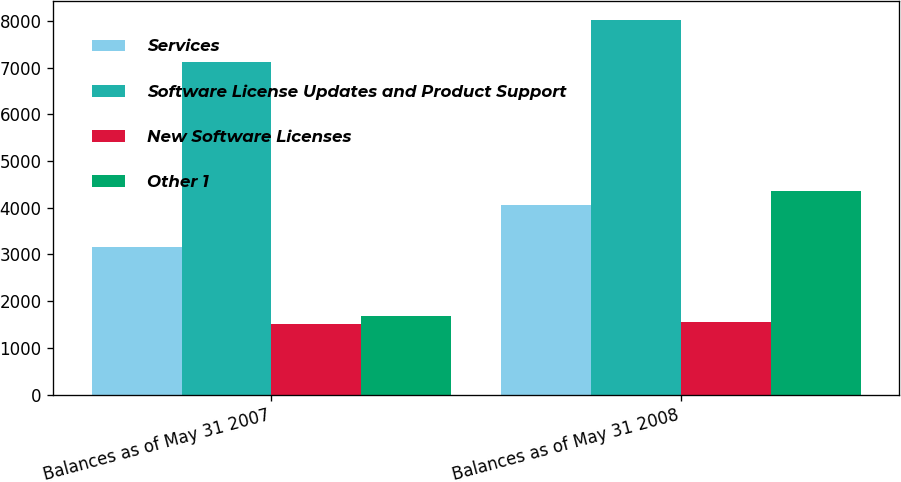Convert chart to OTSL. <chart><loc_0><loc_0><loc_500><loc_500><stacked_bar_chart><ecel><fcel>Balances as of May 31 2007<fcel>Balances as of May 31 2008<nl><fcel>Services<fcel>3169<fcel>4058<nl><fcel>Software License Updates and Product Support<fcel>7122<fcel>8028<nl><fcel>New Software Licenses<fcel>1505<fcel>1550<nl><fcel>Other 1<fcel>1683<fcel>4355<nl></chart> 